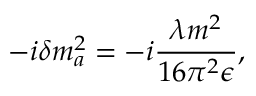Convert formula to latex. <formula><loc_0><loc_0><loc_500><loc_500>- i \delta m _ { a } ^ { 2 } = - i \frac { \lambda m ^ { 2 } } { 1 6 \pi ^ { 2 } \epsilon } ,</formula> 